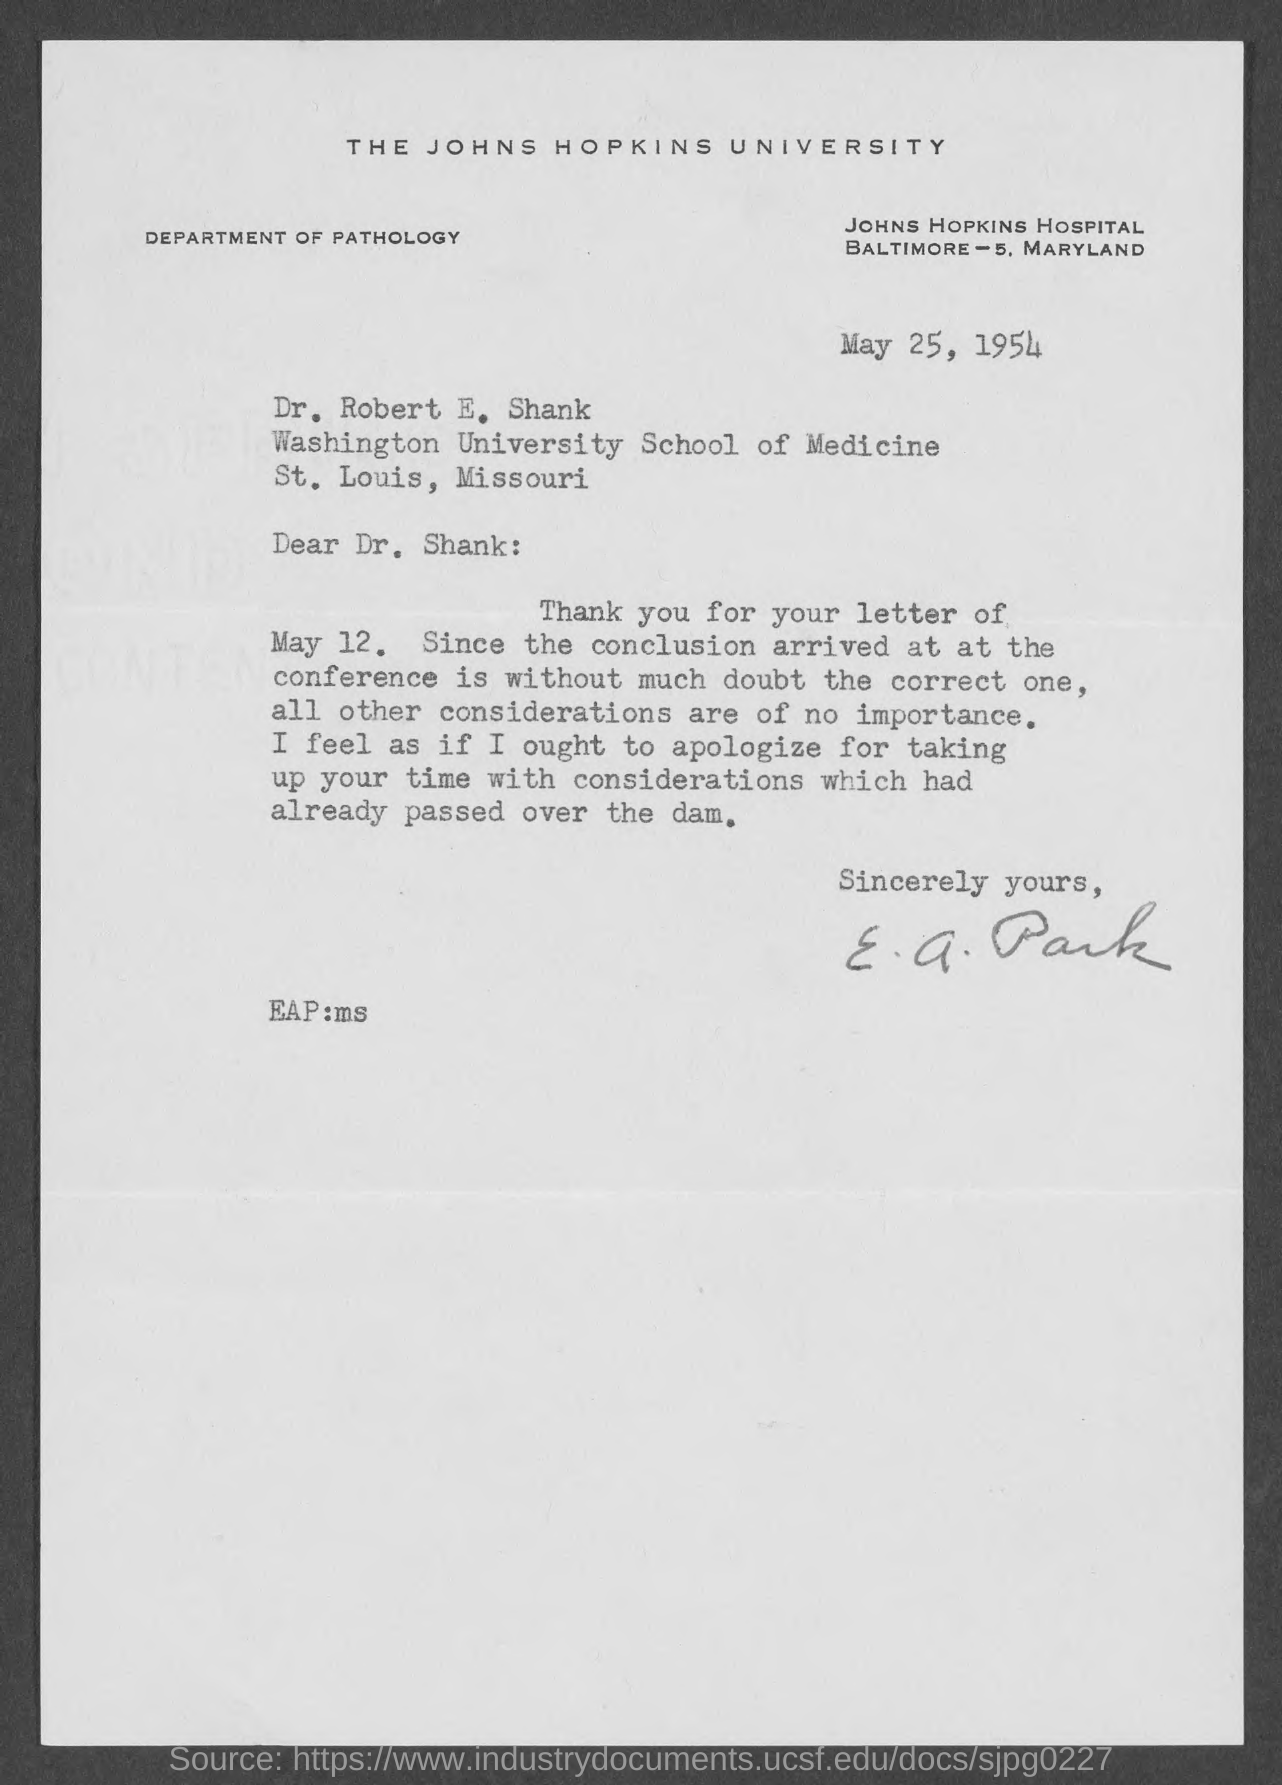Outline some significant characteristics in this image. The issued date of this letter is May 25, 1954. The sender of the letter is E. The letter head mentions The Johns Hopkins University. 